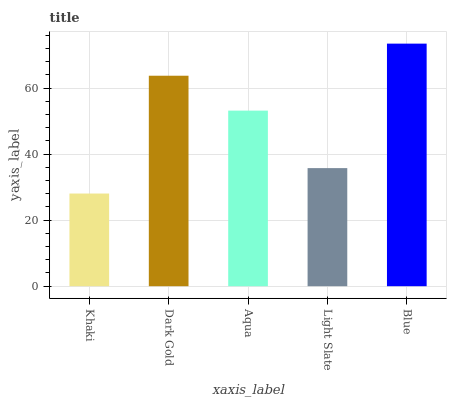Is Khaki the minimum?
Answer yes or no. Yes. Is Blue the maximum?
Answer yes or no. Yes. Is Dark Gold the minimum?
Answer yes or no. No. Is Dark Gold the maximum?
Answer yes or no. No. Is Dark Gold greater than Khaki?
Answer yes or no. Yes. Is Khaki less than Dark Gold?
Answer yes or no. Yes. Is Khaki greater than Dark Gold?
Answer yes or no. No. Is Dark Gold less than Khaki?
Answer yes or no. No. Is Aqua the high median?
Answer yes or no. Yes. Is Aqua the low median?
Answer yes or no. Yes. Is Dark Gold the high median?
Answer yes or no. No. Is Blue the low median?
Answer yes or no. No. 